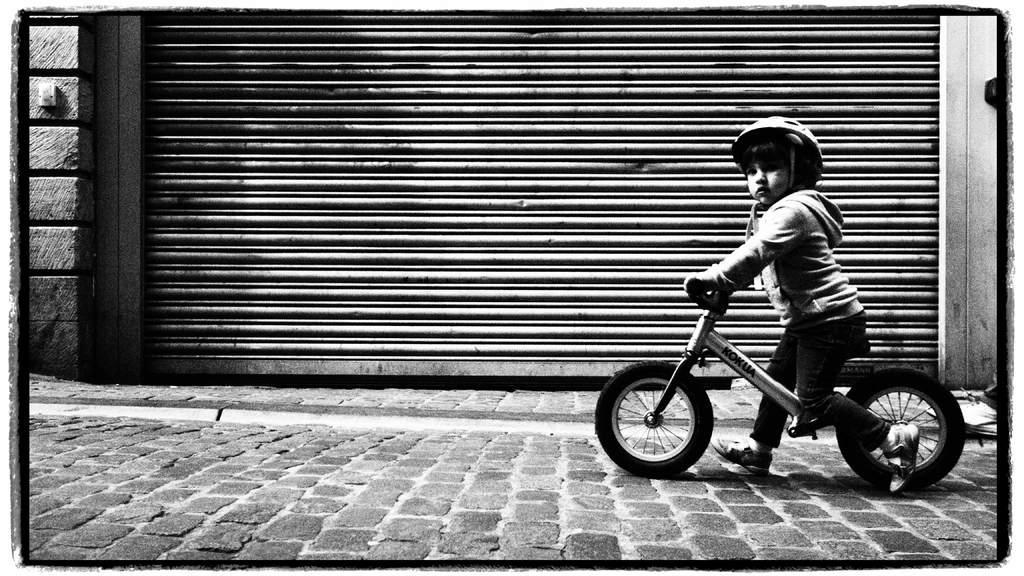Describe this image in one or two sentences. There is a boy riding a bicycle on the sidewalk. In the background there is a fence. 